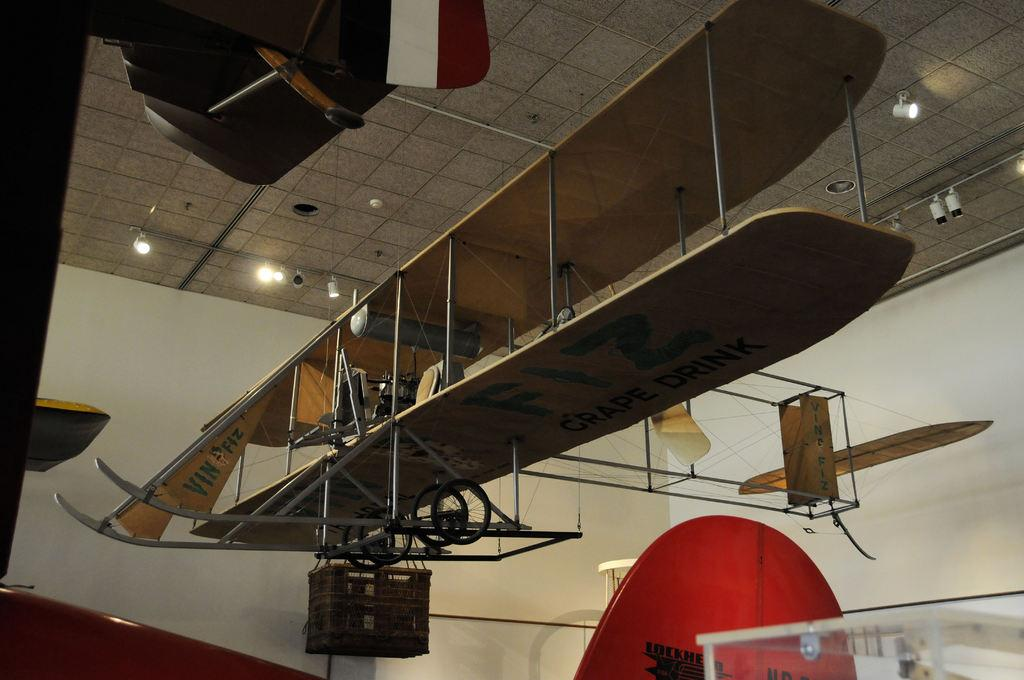What is the main subject of the image? The main subject of the image is an aircraft. What can be seen on the aircraft? There is text on the aircraft. What else is present in the image besides the aircraft? There are objects in the image. What is the name of the daughter of the pilot flying the aircraft in the image? There is no information about the pilot or any passengers in the image, so we cannot determine the name of the pilot's daughter. What type of structure is visible in the background of the image? There is no structure visible in the background of the image; it only features the aircraft and other unspecified objects. 